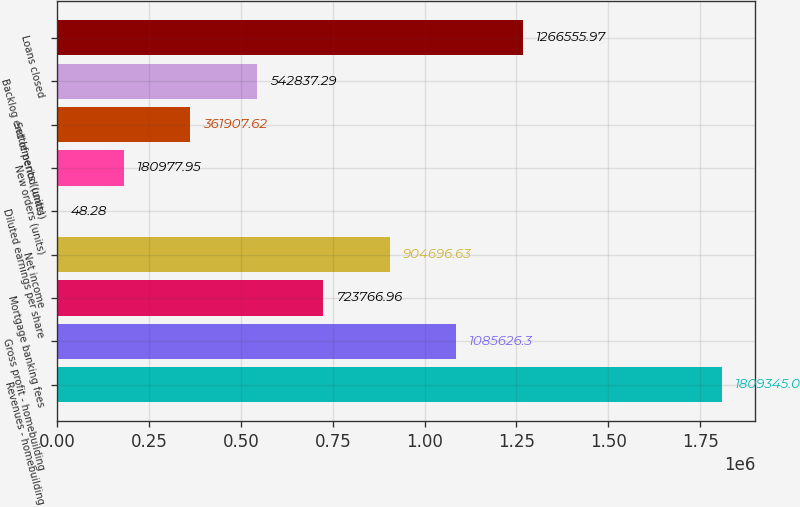Convert chart. <chart><loc_0><loc_0><loc_500><loc_500><bar_chart><fcel>Revenues - homebuilding<fcel>Gross profit - homebuilding<fcel>Mortgage banking fees<fcel>Net income<fcel>Diluted earnings per share<fcel>New orders (units)<fcel>Settlements (units)<fcel>Backlog end of period (units)<fcel>Loans closed<nl><fcel>1.80934e+06<fcel>1.08563e+06<fcel>723767<fcel>904697<fcel>48.28<fcel>180978<fcel>361908<fcel>542837<fcel>1.26656e+06<nl></chart> 